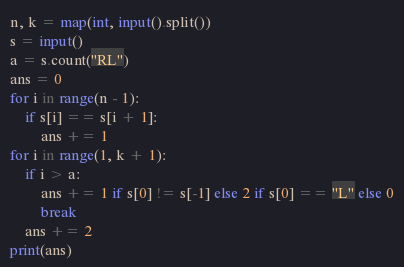<code> <loc_0><loc_0><loc_500><loc_500><_Python_>n, k = map(int, input().split())
s = input()
a = s.count("RL")
ans = 0
for i in range(n - 1):
    if s[i] == s[i + 1]:
        ans += 1
for i in range(1, k + 1):
    if i > a:
        ans += 1 if s[0] != s[-1] else 2 if s[0] == "L" else 0
        break
    ans += 2
print(ans)
</code> 